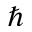<formula> <loc_0><loc_0><loc_500><loc_500>\hbar</formula> 